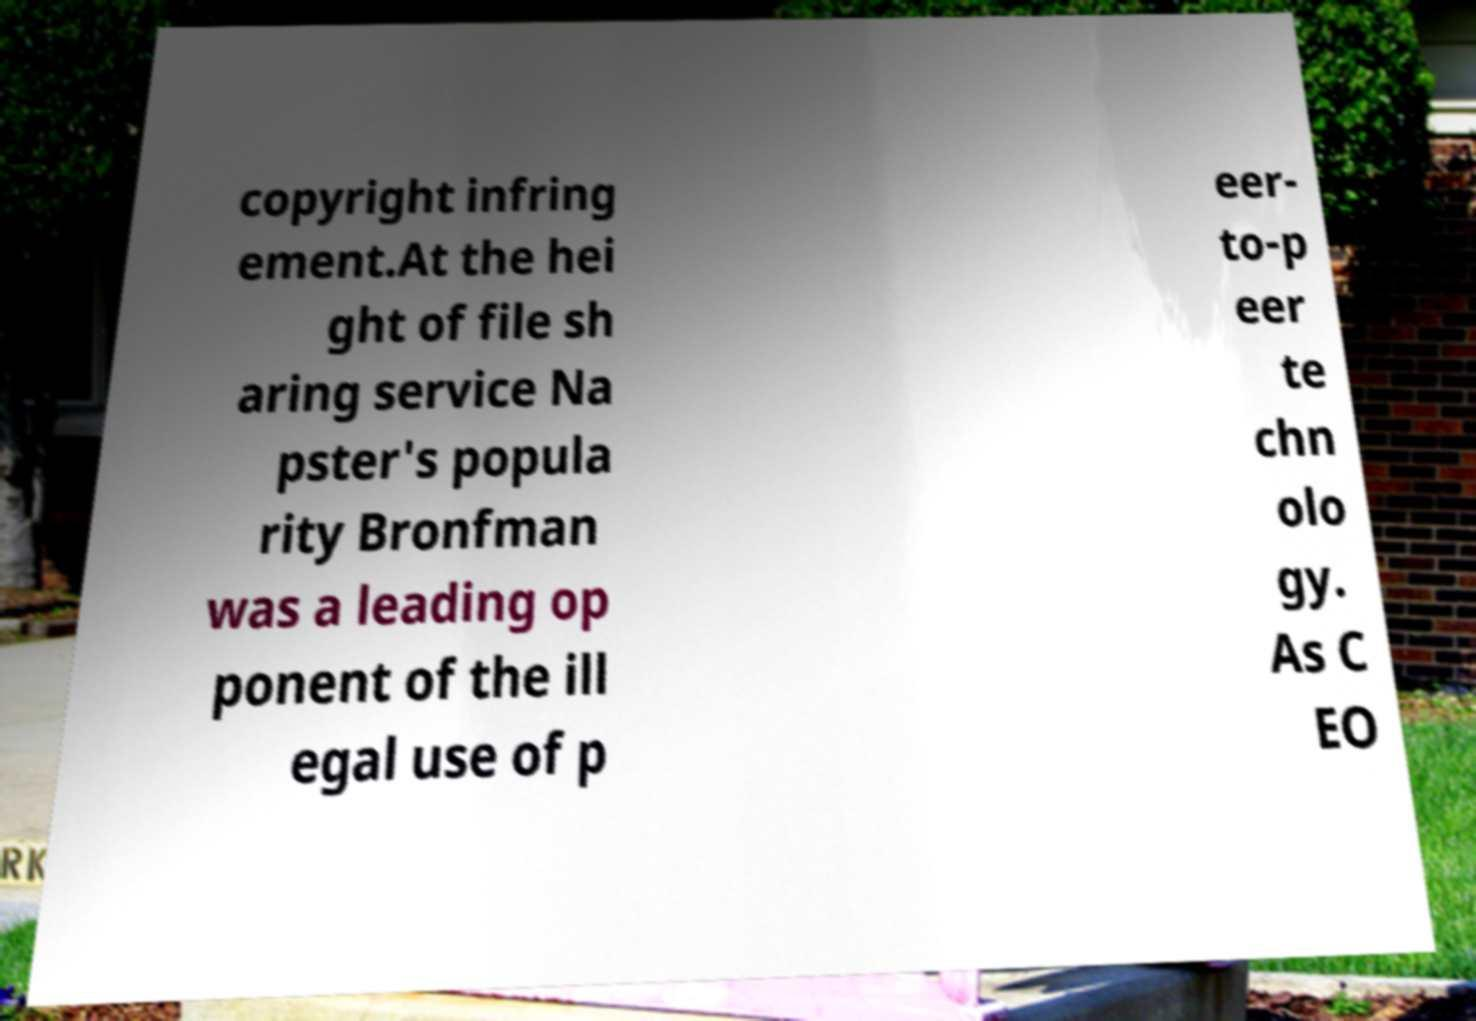There's text embedded in this image that I need extracted. Can you transcribe it verbatim? copyright infring ement.At the hei ght of file sh aring service Na pster's popula rity Bronfman was a leading op ponent of the ill egal use of p eer- to-p eer te chn olo gy. As C EO 